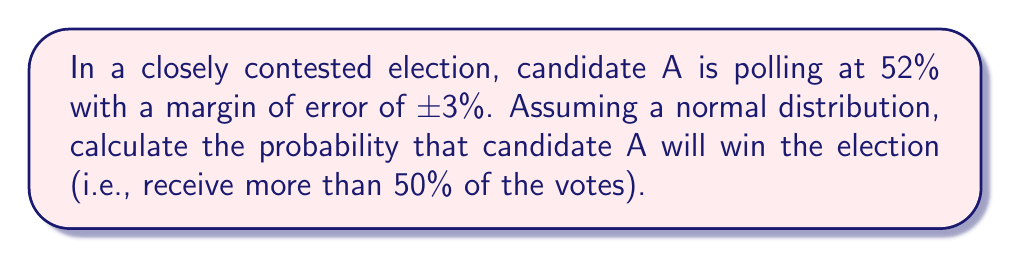Can you solve this math problem? To solve this problem, we'll follow these steps:

1) First, we need to understand what the margin of error means. In this case, it implies that the true percentage for candidate A is likely to fall within the range of 49% to 55% (52% ± 3%).

2) We're assuming a normal distribution, so we can use the properties of the standard normal distribution to calculate the probability.

3) We need to find the z-score for the 50% threshold. The formula for z-score is:

   $$z = \frac{x - \mu}{\sigma}$$

   Where:
   $x$ is the value we're interested in (50%)
   $\mu$ is the mean (52%)
   $\sigma$ is the standard deviation

4) The margin of error (3%) represents about 2 standard deviations in a normal distribution. So, one standard deviation is about 1.5%.

5) Now we can calculate the z-score:

   $$z = \frac{50\% - 52\%}{1.5\%} = -1.33$$

6) To find the probability that candidate A will win, we need to find the area under the normal curve to the right of z = -1.33.

7) Using a standard normal distribution table or calculator, we can find that the area to the left of z = -1.33 is approximately 0.0918.

8) Therefore, the area to the right of z = -1.33 (the probability of winning) is:

   $$1 - 0.0918 = 0.9082 \text{ or about } 90.82\%$$
Answer: $90.82\%$ 